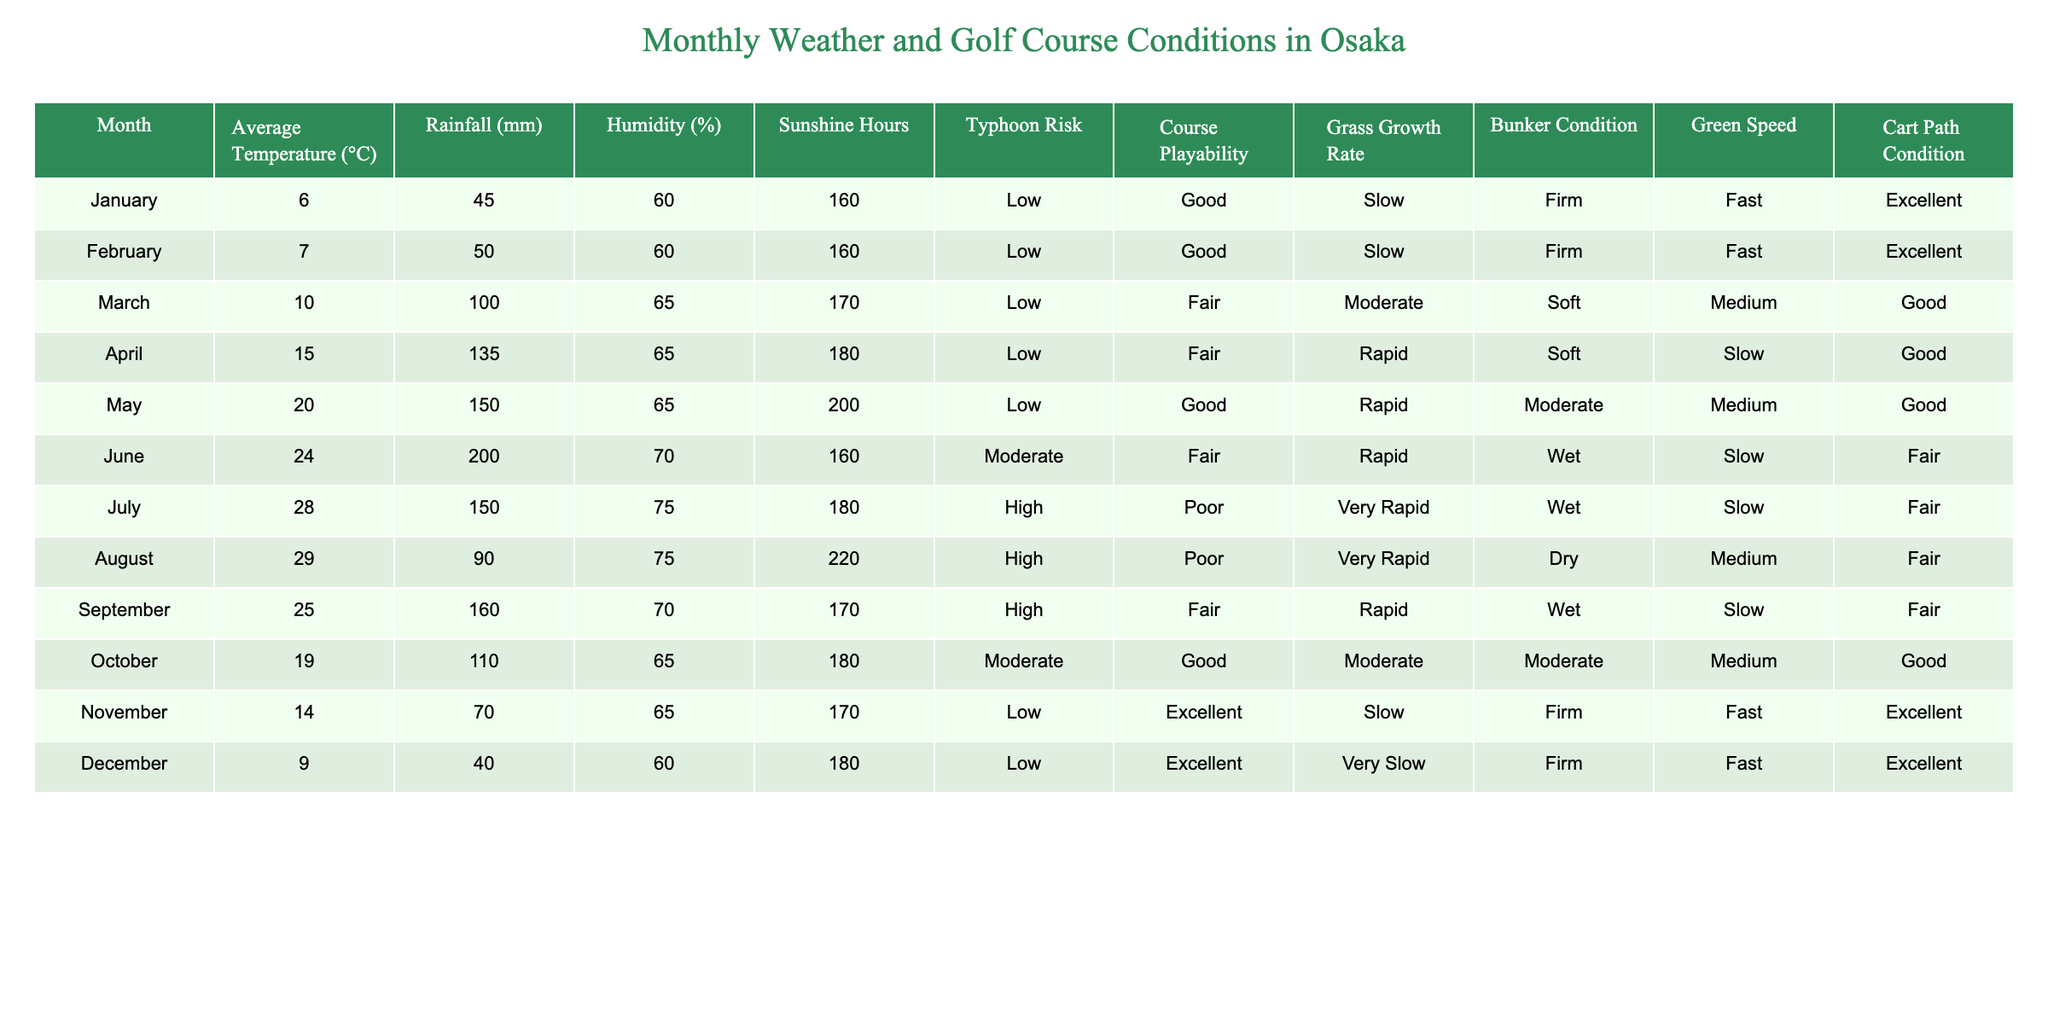What is the average temperature in Osaka during July? The table shows that the average temperature for July is 28°C.
Answer: 28°C What month has the highest rainfall, and how much is it? The table indicates that June has the highest rainfall at 200 mm.
Answer: June, 200 mm During which month is the risk of typhoon considered high? The table lists July and August as the months with high typhoon risk.
Answer: July and August How does the grass growth rate change from January to March? The grass growth rate changes from slow in January (0) to moderate in March (1), indicating an improvement from winter to early spring.
Answer: It increases from slow to moderate What is the condition of golf courses in August, and what is its corresponding green speed? The table shows that the course playability in August is poor, and the green speed is slow.
Answer: Poor, Slow In which month is the bunker condition considered wet, and what is the impact on playability that month? According to the table, July has a wet bunker condition, and the course playability is listed as poor for that month.
Answer: July, Poor What is the average humidity percentage in the months from June to September? The average humidity for June (70%), July (75%), August (75%), and September (70%) is calculated as (70 + 75 + 75 + 70) / 4 = 72.5%.
Answer: 72.5% Is the course condition in November better than that in March? The course condition in November is excellent, while in March it is only fair, indicating better conditions in November.
Answer: Yes How does the sunshine hour vary between the months of January and October? January has 160 sunshine hours, while October has 180, showing an increase of 20 hours from January to October.
Answer: Increases by 20 hours What is the relationship between rainfall and course playability in July? In July, rainfall is 150 mm, and course playability is poor, indicating that high rainfall negatively affects playability.
Answer: Negative relationship Is the average temperature in April higher than in October, and by how much? April has an average temperature of 15°C, while October has 19°C, so October is higher by 4°C.
Answer: Yes, by 4°C How does the grass growth rate in December compare to the growth rate in January? December has a very slow grass growth rate compared to January's slow growth rate, indicating worse growth conditions in December.
Answer: Very slow compared to slow 